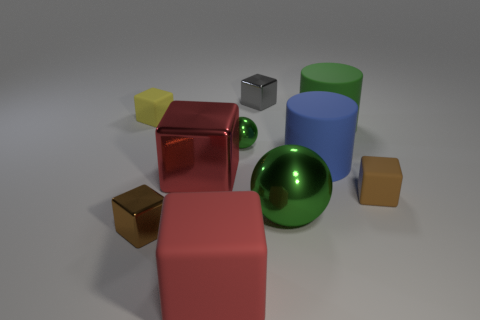Subtract all brown blocks. How many blocks are left? 4 Subtract all yellow cubes. How many cubes are left? 5 Subtract all blocks. How many objects are left? 4 Subtract 1 cylinders. How many cylinders are left? 1 Subtract all yellow blocks. How many brown spheres are left? 0 Subtract all red rubber objects. Subtract all tiny gray matte cubes. How many objects are left? 9 Add 1 brown shiny blocks. How many brown shiny blocks are left? 2 Add 6 tiny blue matte objects. How many tiny blue matte objects exist? 6 Subtract 0 cyan cubes. How many objects are left? 10 Subtract all cyan balls. Subtract all brown cylinders. How many balls are left? 2 